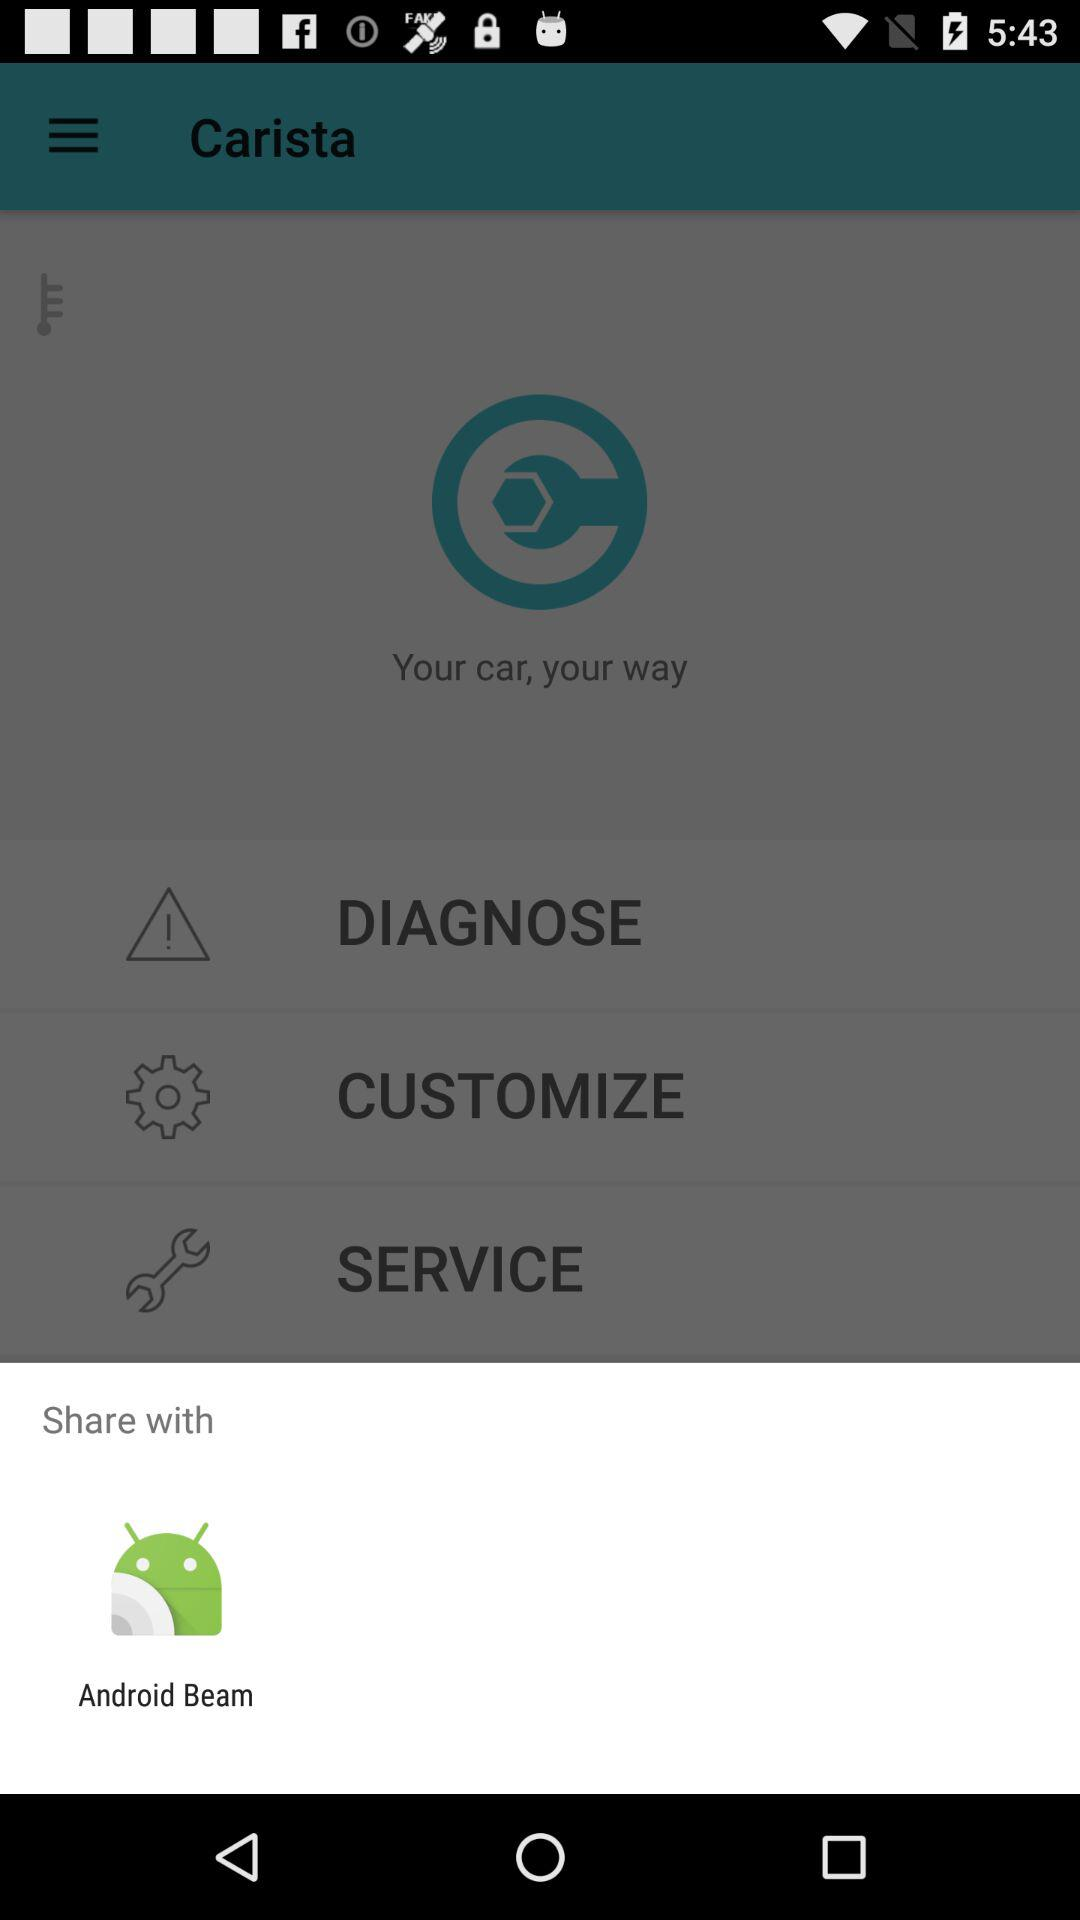Which option is given for sharing? The option given for sharing is "Android Beam". 